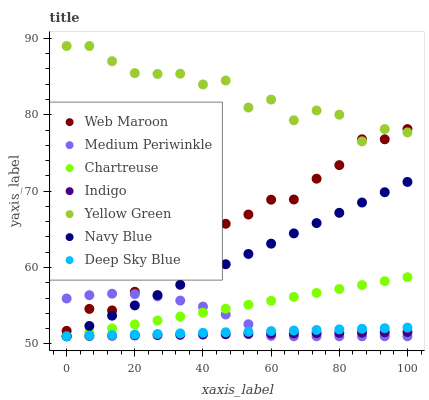Does Indigo have the minimum area under the curve?
Answer yes or no. Yes. Does Yellow Green have the maximum area under the curve?
Answer yes or no. Yes. Does Web Maroon have the minimum area under the curve?
Answer yes or no. No. Does Web Maroon have the maximum area under the curve?
Answer yes or no. No. Is Indigo the smoothest?
Answer yes or no. Yes. Is Yellow Green the roughest?
Answer yes or no. Yes. Is Web Maroon the smoothest?
Answer yes or no. No. Is Web Maroon the roughest?
Answer yes or no. No. Does Indigo have the lowest value?
Answer yes or no. Yes. Does Web Maroon have the lowest value?
Answer yes or no. No. Does Yellow Green have the highest value?
Answer yes or no. Yes. Does Web Maroon have the highest value?
Answer yes or no. No. Is Indigo less than Web Maroon?
Answer yes or no. Yes. Is Yellow Green greater than Navy Blue?
Answer yes or no. Yes. Does Web Maroon intersect Medium Periwinkle?
Answer yes or no. Yes. Is Web Maroon less than Medium Periwinkle?
Answer yes or no. No. Is Web Maroon greater than Medium Periwinkle?
Answer yes or no. No. Does Indigo intersect Web Maroon?
Answer yes or no. No. 